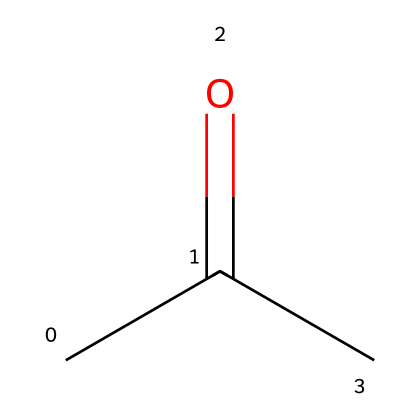What is the common name of this chemical? The SMILES representation shows the structure of a molecule with a carbonyl group (C=O) and a methyl group (C) attached to it, which identifies it as acetone.
Answer: acetone How many carbon atoms are in the structure? Analyzing the SMILES, we see there are two carbon atoms in the propanone group and one more in the carbonyl carbon, totaling three.
Answer: three How many hydrogen atoms are present in acetone? Each carbon in the structure typically bonds with enough hydrogens to fulfill the tetravalency rule. For three carbon atoms in acetone, there are six hydrogen atoms.
Answer: six What functional group does acetone contain? The structure includes a carbonyl group (C=O) and as a keto compound, it is identified as a ketone.
Answer: ketone Why is acetone considered a flammable liquid? The high ratio of hydrogen to carbon in the structure contributes to its volatility and ignitability, allowing it to easily burn in the presence of oxygen.
Answer: volatility Does acetone have a polar or nonpolar structure? While it has polar bonds due to the carbonyl, overall, the molecule displays a slight polarity, suggesting it is polar.
Answer: polar What is a common use for acetone? Acetone is frequently used as a solvent, particularly for removing nail polish and cleaning.
Answer: solvent 